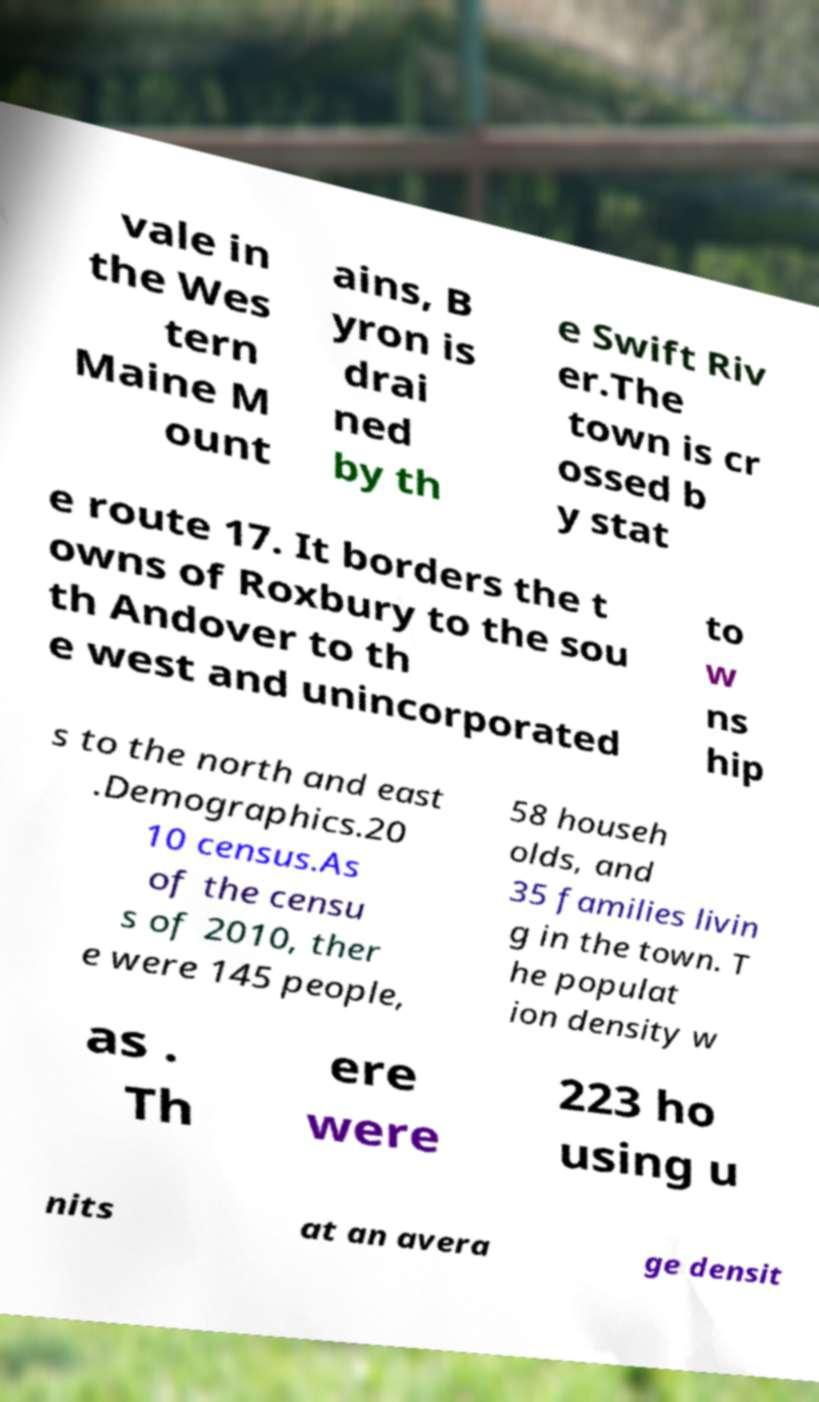There's text embedded in this image that I need extracted. Can you transcribe it verbatim? vale in the Wes tern Maine M ount ains, B yron is drai ned by th e Swift Riv er.The town is cr ossed b y stat e route 17. It borders the t owns of Roxbury to the sou th Andover to th e west and unincorporated to w ns hip s to the north and east .Demographics.20 10 census.As of the censu s of 2010, ther e were 145 people, 58 househ olds, and 35 families livin g in the town. T he populat ion density w as . Th ere were 223 ho using u nits at an avera ge densit 